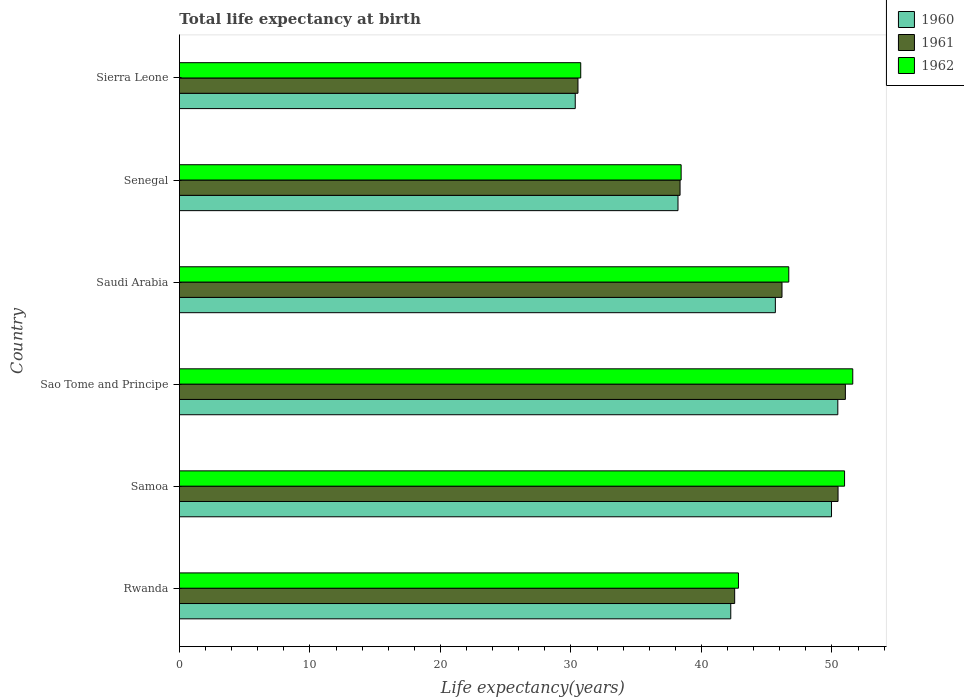Are the number of bars on each tick of the Y-axis equal?
Offer a very short reply. Yes. What is the label of the 3rd group of bars from the top?
Your response must be concise. Saudi Arabia. In how many cases, is the number of bars for a given country not equal to the number of legend labels?
Your response must be concise. 0. What is the life expectancy at birth in in 1962 in Rwanda?
Offer a terse response. 42.84. Across all countries, what is the maximum life expectancy at birth in in 1961?
Offer a terse response. 51.03. Across all countries, what is the minimum life expectancy at birth in in 1960?
Your response must be concise. 30.33. In which country was the life expectancy at birth in in 1961 maximum?
Make the answer very short. Sao Tome and Principe. In which country was the life expectancy at birth in in 1961 minimum?
Offer a terse response. Sierra Leone. What is the total life expectancy at birth in in 1962 in the graph?
Give a very brief answer. 261.3. What is the difference between the life expectancy at birth in in 1960 in Samoa and that in Sierra Leone?
Make the answer very short. 19.64. What is the difference between the life expectancy at birth in in 1960 in Samoa and the life expectancy at birth in in 1961 in Senegal?
Provide a short and direct response. 11.61. What is the average life expectancy at birth in in 1960 per country?
Offer a very short reply. 42.81. What is the difference between the life expectancy at birth in in 1962 and life expectancy at birth in in 1961 in Senegal?
Keep it short and to the point. 0.08. What is the ratio of the life expectancy at birth in in 1961 in Sao Tome and Principe to that in Senegal?
Ensure brevity in your answer.  1.33. Is the life expectancy at birth in in 1962 in Sao Tome and Principe less than that in Saudi Arabia?
Provide a short and direct response. No. What is the difference between the highest and the second highest life expectancy at birth in in 1960?
Give a very brief answer. 0.48. What is the difference between the highest and the lowest life expectancy at birth in in 1961?
Provide a short and direct response. 20.49. In how many countries, is the life expectancy at birth in in 1960 greater than the average life expectancy at birth in in 1960 taken over all countries?
Keep it short and to the point. 3. Is the sum of the life expectancy at birth in in 1961 in Senegal and Sierra Leone greater than the maximum life expectancy at birth in in 1960 across all countries?
Your answer should be compact. Yes. What does the 2nd bar from the top in Samoa represents?
Offer a terse response. 1961. What does the 3rd bar from the bottom in Samoa represents?
Keep it short and to the point. 1962. How many countries are there in the graph?
Offer a terse response. 6. Does the graph contain any zero values?
Offer a very short reply. No. Does the graph contain grids?
Your answer should be compact. No. Where does the legend appear in the graph?
Give a very brief answer. Top right. How many legend labels are there?
Your response must be concise. 3. What is the title of the graph?
Ensure brevity in your answer.  Total life expectancy at birth. What is the label or title of the X-axis?
Your answer should be compact. Life expectancy(years). What is the Life expectancy(years) in 1960 in Rwanda?
Ensure brevity in your answer.  42.25. What is the Life expectancy(years) in 1961 in Rwanda?
Ensure brevity in your answer.  42.55. What is the Life expectancy(years) in 1962 in Rwanda?
Make the answer very short. 42.84. What is the Life expectancy(years) in 1960 in Samoa?
Make the answer very short. 49.97. What is the Life expectancy(years) of 1961 in Samoa?
Your response must be concise. 50.47. What is the Life expectancy(years) in 1962 in Samoa?
Provide a short and direct response. 50.97. What is the Life expectancy(years) in 1960 in Sao Tome and Principe?
Provide a succinct answer. 50.45. What is the Life expectancy(years) of 1961 in Sao Tome and Principe?
Your answer should be very brief. 51.03. What is the Life expectancy(years) of 1962 in Sao Tome and Principe?
Your response must be concise. 51.6. What is the Life expectancy(years) of 1960 in Saudi Arabia?
Offer a very short reply. 45.67. What is the Life expectancy(years) in 1961 in Saudi Arabia?
Provide a succinct answer. 46.17. What is the Life expectancy(years) of 1962 in Saudi Arabia?
Ensure brevity in your answer.  46.69. What is the Life expectancy(years) of 1960 in Senegal?
Give a very brief answer. 38.21. What is the Life expectancy(years) of 1961 in Senegal?
Make the answer very short. 38.36. What is the Life expectancy(years) in 1962 in Senegal?
Your response must be concise. 38.45. What is the Life expectancy(years) of 1960 in Sierra Leone?
Keep it short and to the point. 30.33. What is the Life expectancy(years) in 1961 in Sierra Leone?
Keep it short and to the point. 30.54. What is the Life expectancy(years) in 1962 in Sierra Leone?
Ensure brevity in your answer.  30.75. Across all countries, what is the maximum Life expectancy(years) of 1960?
Ensure brevity in your answer.  50.45. Across all countries, what is the maximum Life expectancy(years) in 1961?
Offer a very short reply. 51.03. Across all countries, what is the maximum Life expectancy(years) of 1962?
Ensure brevity in your answer.  51.6. Across all countries, what is the minimum Life expectancy(years) in 1960?
Your answer should be compact. 30.33. Across all countries, what is the minimum Life expectancy(years) in 1961?
Make the answer very short. 30.54. Across all countries, what is the minimum Life expectancy(years) of 1962?
Your response must be concise. 30.75. What is the total Life expectancy(years) of 1960 in the graph?
Your answer should be compact. 256.87. What is the total Life expectancy(years) in 1961 in the graph?
Your answer should be very brief. 259.13. What is the total Life expectancy(years) in 1962 in the graph?
Your response must be concise. 261.3. What is the difference between the Life expectancy(years) of 1960 in Rwanda and that in Samoa?
Ensure brevity in your answer.  -7.72. What is the difference between the Life expectancy(years) in 1961 in Rwanda and that in Samoa?
Make the answer very short. -7.92. What is the difference between the Life expectancy(years) in 1962 in Rwanda and that in Samoa?
Provide a short and direct response. -8.13. What is the difference between the Life expectancy(years) in 1960 in Rwanda and that in Sao Tome and Principe?
Offer a very short reply. -8.2. What is the difference between the Life expectancy(years) in 1961 in Rwanda and that in Sao Tome and Principe?
Provide a short and direct response. -8.48. What is the difference between the Life expectancy(years) of 1962 in Rwanda and that in Sao Tome and Principe?
Provide a succinct answer. -8.76. What is the difference between the Life expectancy(years) in 1960 in Rwanda and that in Saudi Arabia?
Make the answer very short. -3.42. What is the difference between the Life expectancy(years) of 1961 in Rwanda and that in Saudi Arabia?
Give a very brief answer. -3.63. What is the difference between the Life expectancy(years) in 1962 in Rwanda and that in Saudi Arabia?
Offer a very short reply. -3.86. What is the difference between the Life expectancy(years) in 1960 in Rwanda and that in Senegal?
Give a very brief answer. 4.04. What is the difference between the Life expectancy(years) of 1961 in Rwanda and that in Senegal?
Ensure brevity in your answer.  4.19. What is the difference between the Life expectancy(years) of 1962 in Rwanda and that in Senegal?
Offer a terse response. 4.39. What is the difference between the Life expectancy(years) in 1960 in Rwanda and that in Sierra Leone?
Make the answer very short. 11.92. What is the difference between the Life expectancy(years) in 1961 in Rwanda and that in Sierra Leone?
Make the answer very short. 12.01. What is the difference between the Life expectancy(years) in 1962 in Rwanda and that in Sierra Leone?
Provide a short and direct response. 12.08. What is the difference between the Life expectancy(years) of 1960 in Samoa and that in Sao Tome and Principe?
Your response must be concise. -0.48. What is the difference between the Life expectancy(years) in 1961 in Samoa and that in Sao Tome and Principe?
Your answer should be very brief. -0.56. What is the difference between the Life expectancy(years) in 1962 in Samoa and that in Sao Tome and Principe?
Make the answer very short. -0.63. What is the difference between the Life expectancy(years) of 1960 in Samoa and that in Saudi Arabia?
Keep it short and to the point. 4.3. What is the difference between the Life expectancy(years) in 1961 in Samoa and that in Saudi Arabia?
Offer a terse response. 4.3. What is the difference between the Life expectancy(years) of 1962 in Samoa and that in Saudi Arabia?
Give a very brief answer. 4.28. What is the difference between the Life expectancy(years) of 1960 in Samoa and that in Senegal?
Ensure brevity in your answer.  11.76. What is the difference between the Life expectancy(years) of 1961 in Samoa and that in Senegal?
Ensure brevity in your answer.  12.11. What is the difference between the Life expectancy(years) in 1962 in Samoa and that in Senegal?
Offer a terse response. 12.52. What is the difference between the Life expectancy(years) in 1960 in Samoa and that in Sierra Leone?
Your answer should be very brief. 19.64. What is the difference between the Life expectancy(years) in 1961 in Samoa and that in Sierra Leone?
Make the answer very short. 19.93. What is the difference between the Life expectancy(years) of 1962 in Samoa and that in Sierra Leone?
Give a very brief answer. 20.22. What is the difference between the Life expectancy(years) in 1960 in Sao Tome and Principe and that in Saudi Arabia?
Offer a very short reply. 4.79. What is the difference between the Life expectancy(years) of 1961 in Sao Tome and Principe and that in Saudi Arabia?
Your response must be concise. 4.86. What is the difference between the Life expectancy(years) of 1962 in Sao Tome and Principe and that in Saudi Arabia?
Ensure brevity in your answer.  4.9. What is the difference between the Life expectancy(years) in 1960 in Sao Tome and Principe and that in Senegal?
Make the answer very short. 12.25. What is the difference between the Life expectancy(years) in 1961 in Sao Tome and Principe and that in Senegal?
Your answer should be compact. 12.67. What is the difference between the Life expectancy(years) in 1962 in Sao Tome and Principe and that in Senegal?
Ensure brevity in your answer.  13.15. What is the difference between the Life expectancy(years) of 1960 in Sao Tome and Principe and that in Sierra Leone?
Ensure brevity in your answer.  20.12. What is the difference between the Life expectancy(years) of 1961 in Sao Tome and Principe and that in Sierra Leone?
Keep it short and to the point. 20.49. What is the difference between the Life expectancy(years) of 1962 in Sao Tome and Principe and that in Sierra Leone?
Offer a terse response. 20.84. What is the difference between the Life expectancy(years) of 1960 in Saudi Arabia and that in Senegal?
Offer a very short reply. 7.46. What is the difference between the Life expectancy(years) in 1961 in Saudi Arabia and that in Senegal?
Your answer should be compact. 7.81. What is the difference between the Life expectancy(years) in 1962 in Saudi Arabia and that in Senegal?
Your response must be concise. 8.25. What is the difference between the Life expectancy(years) of 1960 in Saudi Arabia and that in Sierra Leone?
Ensure brevity in your answer.  15.33. What is the difference between the Life expectancy(years) of 1961 in Saudi Arabia and that in Sierra Leone?
Offer a terse response. 15.63. What is the difference between the Life expectancy(years) in 1962 in Saudi Arabia and that in Sierra Leone?
Provide a succinct answer. 15.94. What is the difference between the Life expectancy(years) of 1960 in Senegal and that in Sierra Leone?
Your response must be concise. 7.87. What is the difference between the Life expectancy(years) of 1961 in Senegal and that in Sierra Leone?
Your response must be concise. 7.82. What is the difference between the Life expectancy(years) in 1962 in Senegal and that in Sierra Leone?
Offer a terse response. 7.69. What is the difference between the Life expectancy(years) of 1960 in Rwanda and the Life expectancy(years) of 1961 in Samoa?
Offer a terse response. -8.22. What is the difference between the Life expectancy(years) of 1960 in Rwanda and the Life expectancy(years) of 1962 in Samoa?
Your answer should be very brief. -8.72. What is the difference between the Life expectancy(years) in 1961 in Rwanda and the Life expectancy(years) in 1962 in Samoa?
Give a very brief answer. -8.42. What is the difference between the Life expectancy(years) in 1960 in Rwanda and the Life expectancy(years) in 1961 in Sao Tome and Principe?
Provide a short and direct response. -8.78. What is the difference between the Life expectancy(years) of 1960 in Rwanda and the Life expectancy(years) of 1962 in Sao Tome and Principe?
Provide a succinct answer. -9.35. What is the difference between the Life expectancy(years) in 1961 in Rwanda and the Life expectancy(years) in 1962 in Sao Tome and Principe?
Give a very brief answer. -9.05. What is the difference between the Life expectancy(years) in 1960 in Rwanda and the Life expectancy(years) in 1961 in Saudi Arabia?
Give a very brief answer. -3.93. What is the difference between the Life expectancy(years) of 1960 in Rwanda and the Life expectancy(years) of 1962 in Saudi Arabia?
Provide a short and direct response. -4.45. What is the difference between the Life expectancy(years) of 1961 in Rwanda and the Life expectancy(years) of 1962 in Saudi Arabia?
Your answer should be compact. -4.15. What is the difference between the Life expectancy(years) in 1960 in Rwanda and the Life expectancy(years) in 1961 in Senegal?
Ensure brevity in your answer.  3.89. What is the difference between the Life expectancy(years) of 1960 in Rwanda and the Life expectancy(years) of 1962 in Senegal?
Provide a succinct answer. 3.8. What is the difference between the Life expectancy(years) in 1961 in Rwanda and the Life expectancy(years) in 1962 in Senegal?
Your response must be concise. 4.1. What is the difference between the Life expectancy(years) of 1960 in Rwanda and the Life expectancy(years) of 1961 in Sierra Leone?
Provide a short and direct response. 11.71. What is the difference between the Life expectancy(years) in 1960 in Rwanda and the Life expectancy(years) in 1962 in Sierra Leone?
Your answer should be very brief. 11.5. What is the difference between the Life expectancy(years) of 1961 in Rwanda and the Life expectancy(years) of 1962 in Sierra Leone?
Your response must be concise. 11.8. What is the difference between the Life expectancy(years) in 1960 in Samoa and the Life expectancy(years) in 1961 in Sao Tome and Principe?
Make the answer very short. -1.06. What is the difference between the Life expectancy(years) in 1960 in Samoa and the Life expectancy(years) in 1962 in Sao Tome and Principe?
Provide a short and direct response. -1.63. What is the difference between the Life expectancy(years) of 1961 in Samoa and the Life expectancy(years) of 1962 in Sao Tome and Principe?
Give a very brief answer. -1.13. What is the difference between the Life expectancy(years) in 1960 in Samoa and the Life expectancy(years) in 1961 in Saudi Arabia?
Provide a succinct answer. 3.8. What is the difference between the Life expectancy(years) in 1960 in Samoa and the Life expectancy(years) in 1962 in Saudi Arabia?
Offer a terse response. 3.27. What is the difference between the Life expectancy(years) of 1961 in Samoa and the Life expectancy(years) of 1962 in Saudi Arabia?
Your response must be concise. 3.77. What is the difference between the Life expectancy(years) of 1960 in Samoa and the Life expectancy(years) of 1961 in Senegal?
Offer a terse response. 11.61. What is the difference between the Life expectancy(years) in 1960 in Samoa and the Life expectancy(years) in 1962 in Senegal?
Your answer should be very brief. 11.52. What is the difference between the Life expectancy(years) in 1961 in Samoa and the Life expectancy(years) in 1962 in Senegal?
Give a very brief answer. 12.02. What is the difference between the Life expectancy(years) of 1960 in Samoa and the Life expectancy(years) of 1961 in Sierra Leone?
Give a very brief answer. 19.43. What is the difference between the Life expectancy(years) of 1960 in Samoa and the Life expectancy(years) of 1962 in Sierra Leone?
Give a very brief answer. 19.22. What is the difference between the Life expectancy(years) in 1961 in Samoa and the Life expectancy(years) in 1962 in Sierra Leone?
Provide a short and direct response. 19.72. What is the difference between the Life expectancy(years) of 1960 in Sao Tome and Principe and the Life expectancy(years) of 1961 in Saudi Arabia?
Give a very brief answer. 4.28. What is the difference between the Life expectancy(years) in 1960 in Sao Tome and Principe and the Life expectancy(years) in 1962 in Saudi Arabia?
Provide a succinct answer. 3.76. What is the difference between the Life expectancy(years) of 1961 in Sao Tome and Principe and the Life expectancy(years) of 1962 in Saudi Arabia?
Your answer should be very brief. 4.34. What is the difference between the Life expectancy(years) in 1960 in Sao Tome and Principe and the Life expectancy(years) in 1961 in Senegal?
Provide a succinct answer. 12.09. What is the difference between the Life expectancy(years) of 1960 in Sao Tome and Principe and the Life expectancy(years) of 1962 in Senegal?
Ensure brevity in your answer.  12.01. What is the difference between the Life expectancy(years) of 1961 in Sao Tome and Principe and the Life expectancy(years) of 1962 in Senegal?
Make the answer very short. 12.59. What is the difference between the Life expectancy(years) of 1960 in Sao Tome and Principe and the Life expectancy(years) of 1961 in Sierra Leone?
Keep it short and to the point. 19.91. What is the difference between the Life expectancy(years) in 1960 in Sao Tome and Principe and the Life expectancy(years) in 1962 in Sierra Leone?
Offer a terse response. 19.7. What is the difference between the Life expectancy(years) of 1961 in Sao Tome and Principe and the Life expectancy(years) of 1962 in Sierra Leone?
Provide a short and direct response. 20.28. What is the difference between the Life expectancy(years) in 1960 in Saudi Arabia and the Life expectancy(years) in 1961 in Senegal?
Give a very brief answer. 7.3. What is the difference between the Life expectancy(years) of 1960 in Saudi Arabia and the Life expectancy(years) of 1962 in Senegal?
Keep it short and to the point. 7.22. What is the difference between the Life expectancy(years) in 1961 in Saudi Arabia and the Life expectancy(years) in 1962 in Senegal?
Your response must be concise. 7.73. What is the difference between the Life expectancy(years) in 1960 in Saudi Arabia and the Life expectancy(years) in 1961 in Sierra Leone?
Provide a short and direct response. 15.13. What is the difference between the Life expectancy(years) in 1960 in Saudi Arabia and the Life expectancy(years) in 1962 in Sierra Leone?
Keep it short and to the point. 14.91. What is the difference between the Life expectancy(years) of 1961 in Saudi Arabia and the Life expectancy(years) of 1962 in Sierra Leone?
Offer a very short reply. 15.42. What is the difference between the Life expectancy(years) of 1960 in Senegal and the Life expectancy(years) of 1961 in Sierra Leone?
Your answer should be very brief. 7.67. What is the difference between the Life expectancy(years) in 1960 in Senegal and the Life expectancy(years) in 1962 in Sierra Leone?
Keep it short and to the point. 7.45. What is the difference between the Life expectancy(years) of 1961 in Senegal and the Life expectancy(years) of 1962 in Sierra Leone?
Offer a very short reply. 7.61. What is the average Life expectancy(years) in 1960 per country?
Keep it short and to the point. 42.81. What is the average Life expectancy(years) in 1961 per country?
Provide a short and direct response. 43.19. What is the average Life expectancy(years) in 1962 per country?
Offer a terse response. 43.55. What is the difference between the Life expectancy(years) in 1960 and Life expectancy(years) in 1961 in Rwanda?
Make the answer very short. -0.3. What is the difference between the Life expectancy(years) of 1960 and Life expectancy(years) of 1962 in Rwanda?
Your response must be concise. -0.59. What is the difference between the Life expectancy(years) in 1961 and Life expectancy(years) in 1962 in Rwanda?
Keep it short and to the point. -0.29. What is the difference between the Life expectancy(years) in 1961 and Life expectancy(years) in 1962 in Samoa?
Provide a succinct answer. -0.5. What is the difference between the Life expectancy(years) of 1960 and Life expectancy(years) of 1961 in Sao Tome and Principe?
Provide a short and direct response. -0.58. What is the difference between the Life expectancy(years) of 1960 and Life expectancy(years) of 1962 in Sao Tome and Principe?
Your answer should be very brief. -1.15. What is the difference between the Life expectancy(years) in 1961 and Life expectancy(years) in 1962 in Sao Tome and Principe?
Provide a succinct answer. -0.57. What is the difference between the Life expectancy(years) of 1960 and Life expectancy(years) of 1961 in Saudi Arabia?
Offer a very short reply. -0.51. What is the difference between the Life expectancy(years) of 1960 and Life expectancy(years) of 1962 in Saudi Arabia?
Keep it short and to the point. -1.03. What is the difference between the Life expectancy(years) of 1961 and Life expectancy(years) of 1962 in Saudi Arabia?
Ensure brevity in your answer.  -0.52. What is the difference between the Life expectancy(years) in 1960 and Life expectancy(years) in 1961 in Senegal?
Your answer should be very brief. -0.16. What is the difference between the Life expectancy(years) in 1960 and Life expectancy(years) in 1962 in Senegal?
Give a very brief answer. -0.24. What is the difference between the Life expectancy(years) of 1961 and Life expectancy(years) of 1962 in Senegal?
Your response must be concise. -0.08. What is the difference between the Life expectancy(years) of 1960 and Life expectancy(years) of 1961 in Sierra Leone?
Your response must be concise. -0.21. What is the difference between the Life expectancy(years) of 1960 and Life expectancy(years) of 1962 in Sierra Leone?
Your response must be concise. -0.42. What is the difference between the Life expectancy(years) in 1961 and Life expectancy(years) in 1962 in Sierra Leone?
Keep it short and to the point. -0.21. What is the ratio of the Life expectancy(years) of 1960 in Rwanda to that in Samoa?
Ensure brevity in your answer.  0.85. What is the ratio of the Life expectancy(years) of 1961 in Rwanda to that in Samoa?
Offer a terse response. 0.84. What is the ratio of the Life expectancy(years) of 1962 in Rwanda to that in Samoa?
Ensure brevity in your answer.  0.84. What is the ratio of the Life expectancy(years) in 1960 in Rwanda to that in Sao Tome and Principe?
Your answer should be compact. 0.84. What is the ratio of the Life expectancy(years) of 1961 in Rwanda to that in Sao Tome and Principe?
Your response must be concise. 0.83. What is the ratio of the Life expectancy(years) of 1962 in Rwanda to that in Sao Tome and Principe?
Provide a short and direct response. 0.83. What is the ratio of the Life expectancy(years) in 1960 in Rwanda to that in Saudi Arabia?
Provide a succinct answer. 0.93. What is the ratio of the Life expectancy(years) of 1961 in Rwanda to that in Saudi Arabia?
Provide a short and direct response. 0.92. What is the ratio of the Life expectancy(years) in 1962 in Rwanda to that in Saudi Arabia?
Offer a very short reply. 0.92. What is the ratio of the Life expectancy(years) of 1960 in Rwanda to that in Senegal?
Your answer should be very brief. 1.11. What is the ratio of the Life expectancy(years) of 1961 in Rwanda to that in Senegal?
Your response must be concise. 1.11. What is the ratio of the Life expectancy(years) of 1962 in Rwanda to that in Senegal?
Offer a terse response. 1.11. What is the ratio of the Life expectancy(years) of 1960 in Rwanda to that in Sierra Leone?
Offer a very short reply. 1.39. What is the ratio of the Life expectancy(years) in 1961 in Rwanda to that in Sierra Leone?
Provide a succinct answer. 1.39. What is the ratio of the Life expectancy(years) of 1962 in Rwanda to that in Sierra Leone?
Your answer should be compact. 1.39. What is the ratio of the Life expectancy(years) in 1960 in Samoa to that in Saudi Arabia?
Provide a succinct answer. 1.09. What is the ratio of the Life expectancy(years) in 1961 in Samoa to that in Saudi Arabia?
Your answer should be very brief. 1.09. What is the ratio of the Life expectancy(years) of 1962 in Samoa to that in Saudi Arabia?
Give a very brief answer. 1.09. What is the ratio of the Life expectancy(years) of 1960 in Samoa to that in Senegal?
Provide a short and direct response. 1.31. What is the ratio of the Life expectancy(years) in 1961 in Samoa to that in Senegal?
Ensure brevity in your answer.  1.32. What is the ratio of the Life expectancy(years) in 1962 in Samoa to that in Senegal?
Offer a very short reply. 1.33. What is the ratio of the Life expectancy(years) in 1960 in Samoa to that in Sierra Leone?
Your answer should be very brief. 1.65. What is the ratio of the Life expectancy(years) of 1961 in Samoa to that in Sierra Leone?
Your response must be concise. 1.65. What is the ratio of the Life expectancy(years) in 1962 in Samoa to that in Sierra Leone?
Ensure brevity in your answer.  1.66. What is the ratio of the Life expectancy(years) of 1960 in Sao Tome and Principe to that in Saudi Arabia?
Provide a succinct answer. 1.1. What is the ratio of the Life expectancy(years) in 1961 in Sao Tome and Principe to that in Saudi Arabia?
Provide a short and direct response. 1.11. What is the ratio of the Life expectancy(years) in 1962 in Sao Tome and Principe to that in Saudi Arabia?
Make the answer very short. 1.1. What is the ratio of the Life expectancy(years) of 1960 in Sao Tome and Principe to that in Senegal?
Keep it short and to the point. 1.32. What is the ratio of the Life expectancy(years) in 1961 in Sao Tome and Principe to that in Senegal?
Provide a succinct answer. 1.33. What is the ratio of the Life expectancy(years) in 1962 in Sao Tome and Principe to that in Senegal?
Give a very brief answer. 1.34. What is the ratio of the Life expectancy(years) in 1960 in Sao Tome and Principe to that in Sierra Leone?
Ensure brevity in your answer.  1.66. What is the ratio of the Life expectancy(years) of 1961 in Sao Tome and Principe to that in Sierra Leone?
Ensure brevity in your answer.  1.67. What is the ratio of the Life expectancy(years) in 1962 in Sao Tome and Principe to that in Sierra Leone?
Your response must be concise. 1.68. What is the ratio of the Life expectancy(years) of 1960 in Saudi Arabia to that in Senegal?
Your answer should be compact. 1.2. What is the ratio of the Life expectancy(years) of 1961 in Saudi Arabia to that in Senegal?
Keep it short and to the point. 1.2. What is the ratio of the Life expectancy(years) of 1962 in Saudi Arabia to that in Senegal?
Your answer should be very brief. 1.21. What is the ratio of the Life expectancy(years) of 1960 in Saudi Arabia to that in Sierra Leone?
Your answer should be compact. 1.51. What is the ratio of the Life expectancy(years) of 1961 in Saudi Arabia to that in Sierra Leone?
Your answer should be very brief. 1.51. What is the ratio of the Life expectancy(years) of 1962 in Saudi Arabia to that in Sierra Leone?
Ensure brevity in your answer.  1.52. What is the ratio of the Life expectancy(years) of 1960 in Senegal to that in Sierra Leone?
Offer a very short reply. 1.26. What is the ratio of the Life expectancy(years) of 1961 in Senegal to that in Sierra Leone?
Offer a very short reply. 1.26. What is the ratio of the Life expectancy(years) of 1962 in Senegal to that in Sierra Leone?
Offer a very short reply. 1.25. What is the difference between the highest and the second highest Life expectancy(years) of 1960?
Give a very brief answer. 0.48. What is the difference between the highest and the second highest Life expectancy(years) in 1961?
Offer a very short reply. 0.56. What is the difference between the highest and the second highest Life expectancy(years) in 1962?
Offer a terse response. 0.63. What is the difference between the highest and the lowest Life expectancy(years) in 1960?
Provide a succinct answer. 20.12. What is the difference between the highest and the lowest Life expectancy(years) of 1961?
Make the answer very short. 20.49. What is the difference between the highest and the lowest Life expectancy(years) in 1962?
Your response must be concise. 20.84. 